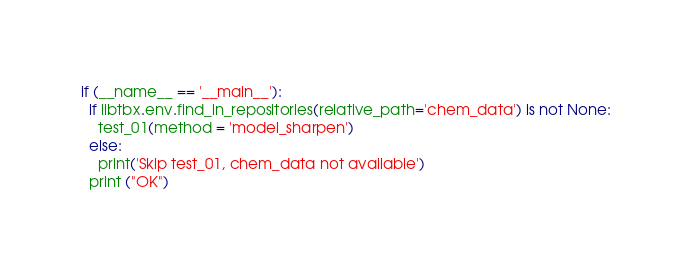<code> <loc_0><loc_0><loc_500><loc_500><_Python_>
if (__name__ == '__main__'):
  if libtbx.env.find_in_repositories(relative_path='chem_data') is not None:
    test_01(method = 'model_sharpen')
  else:
    print('Skip test_01, chem_data not available')
  print ("OK")

</code> 